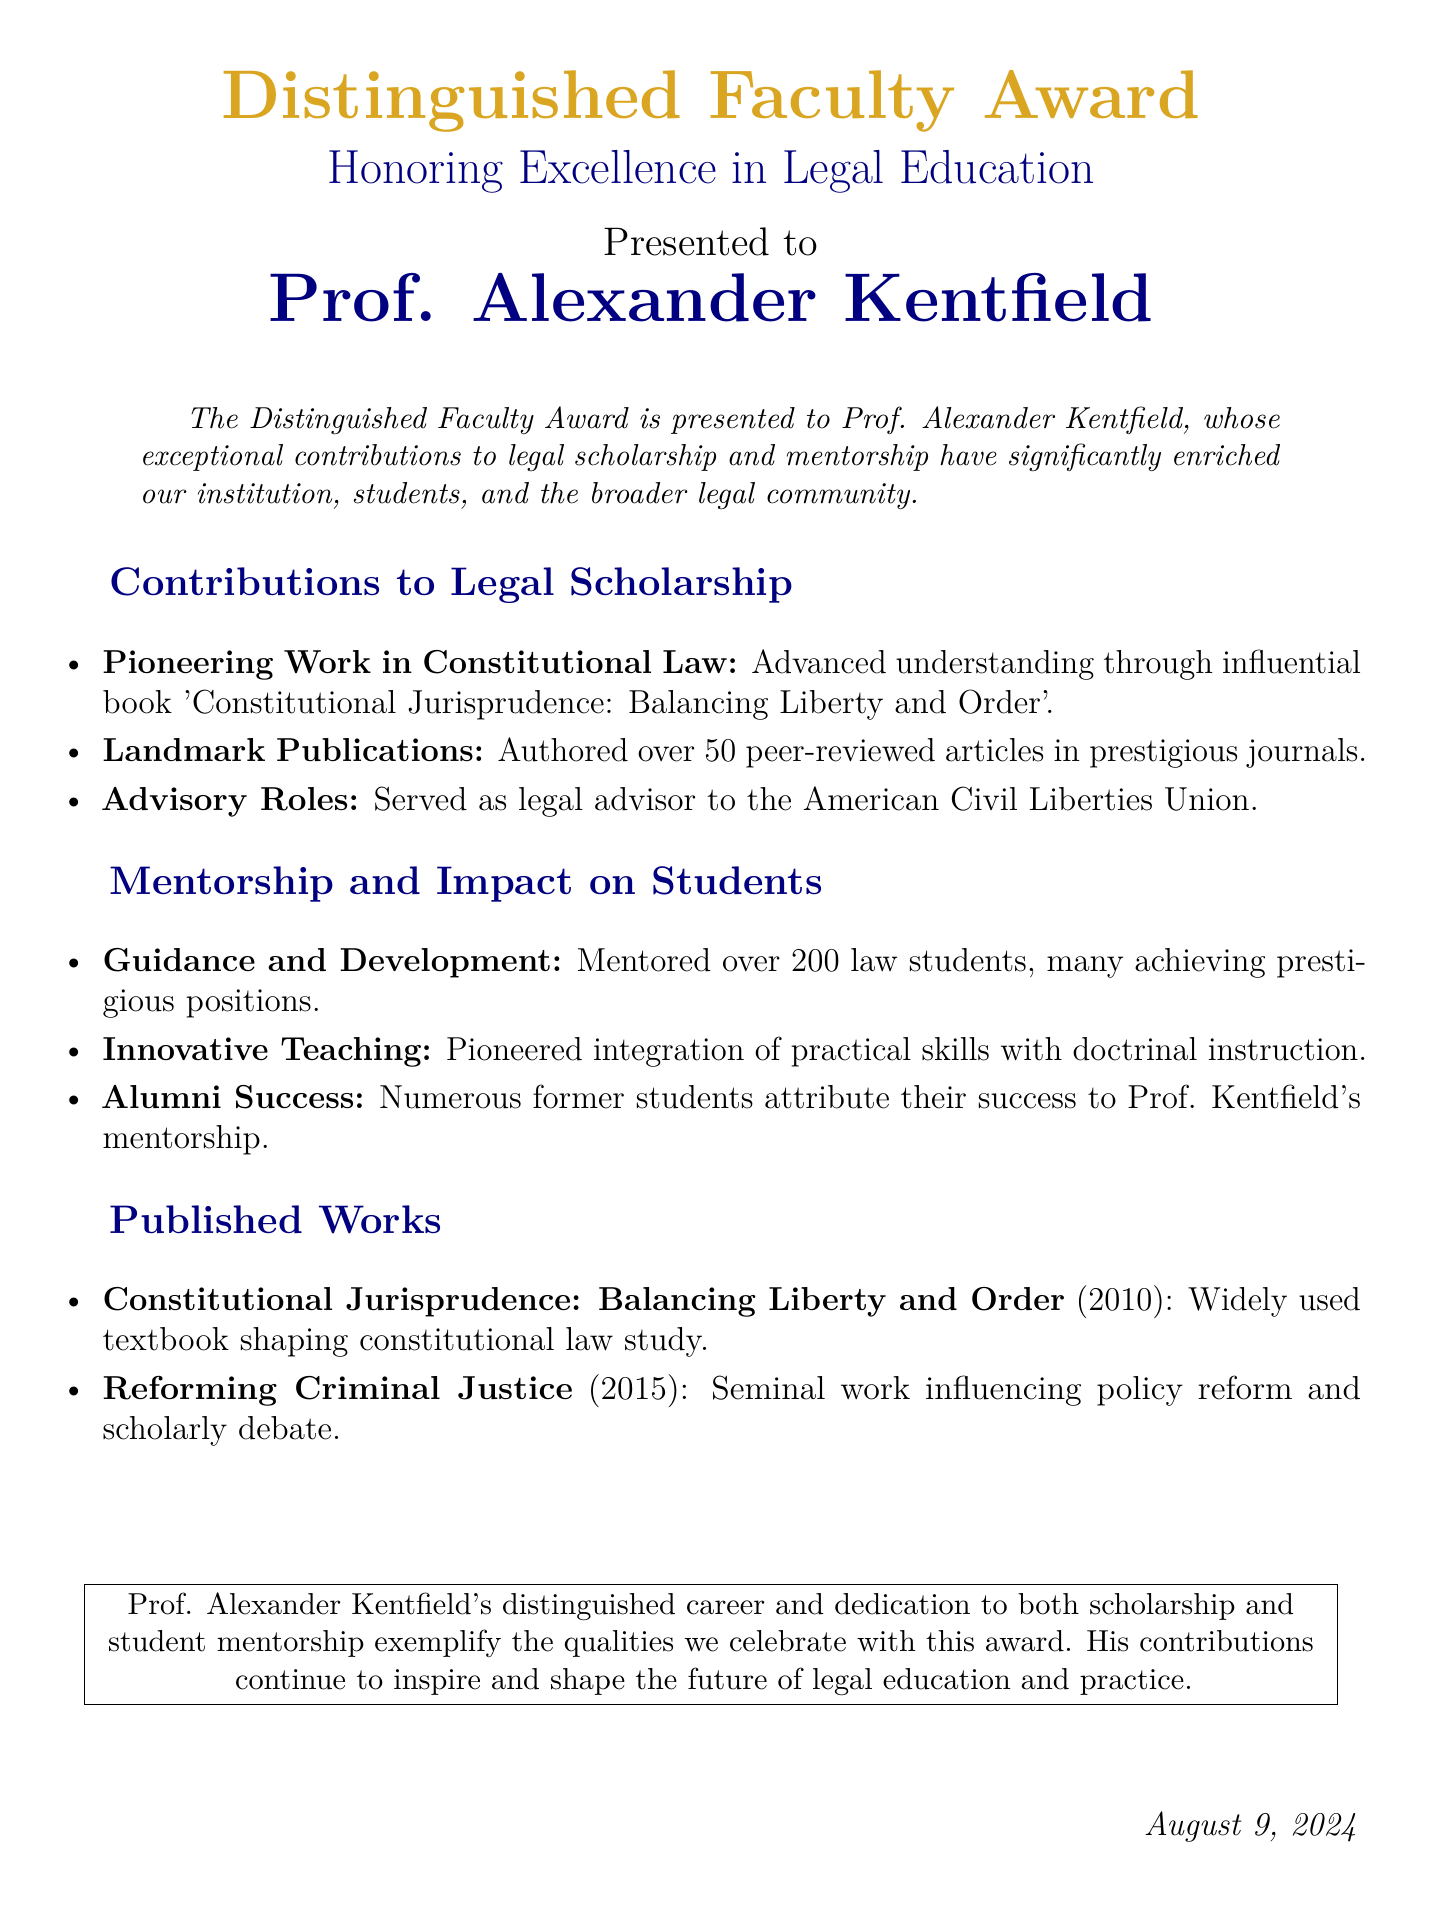What is the title of the award? The title of the award is prominently displayed at the top of the document.
Answer: Distinguished Faculty Award Who is the recipient of the award? The recipient's name is listed below the award title.
Answer: Prof. Alexander Kentfield What year was the book "Constitutional Jurisprudence: Balancing Liberty and Order" published? The year of publication is mentioned in the section "Published Works".
Answer: 2010 How many peer-reviewed articles has Prof. Kentfield authored? The total number of articles authored is provided in the "Contributions to Legal Scholarship" section.
Answer: Over 50 What organization did Prof. Kentfield serve as a legal advisor? The organization is specified in the same section mentioning his advisory roles.
Answer: American Civil Liberties Union How many law students has Prof. Kentfield mentored? The number of mentored students is noted in the "Mentorship and Impact on Students" section.
Answer: Over 200 What is the focus of the book "Reforming Criminal Justice"? The focus of the book is described in the "Published Works" section.
Answer: Policy reform What is highlighted as a key attribute of Prof. Kentfield's teaching methods? The document outlines attributes of his teaching methods in the mentorship section.
Answer: Innovative Teaching What characterizes Prof. Kentfield's contributions to legal education? The document summarizes his contributions at the conclusion.
Answer: Dedicated to both scholarship and student mentorship 